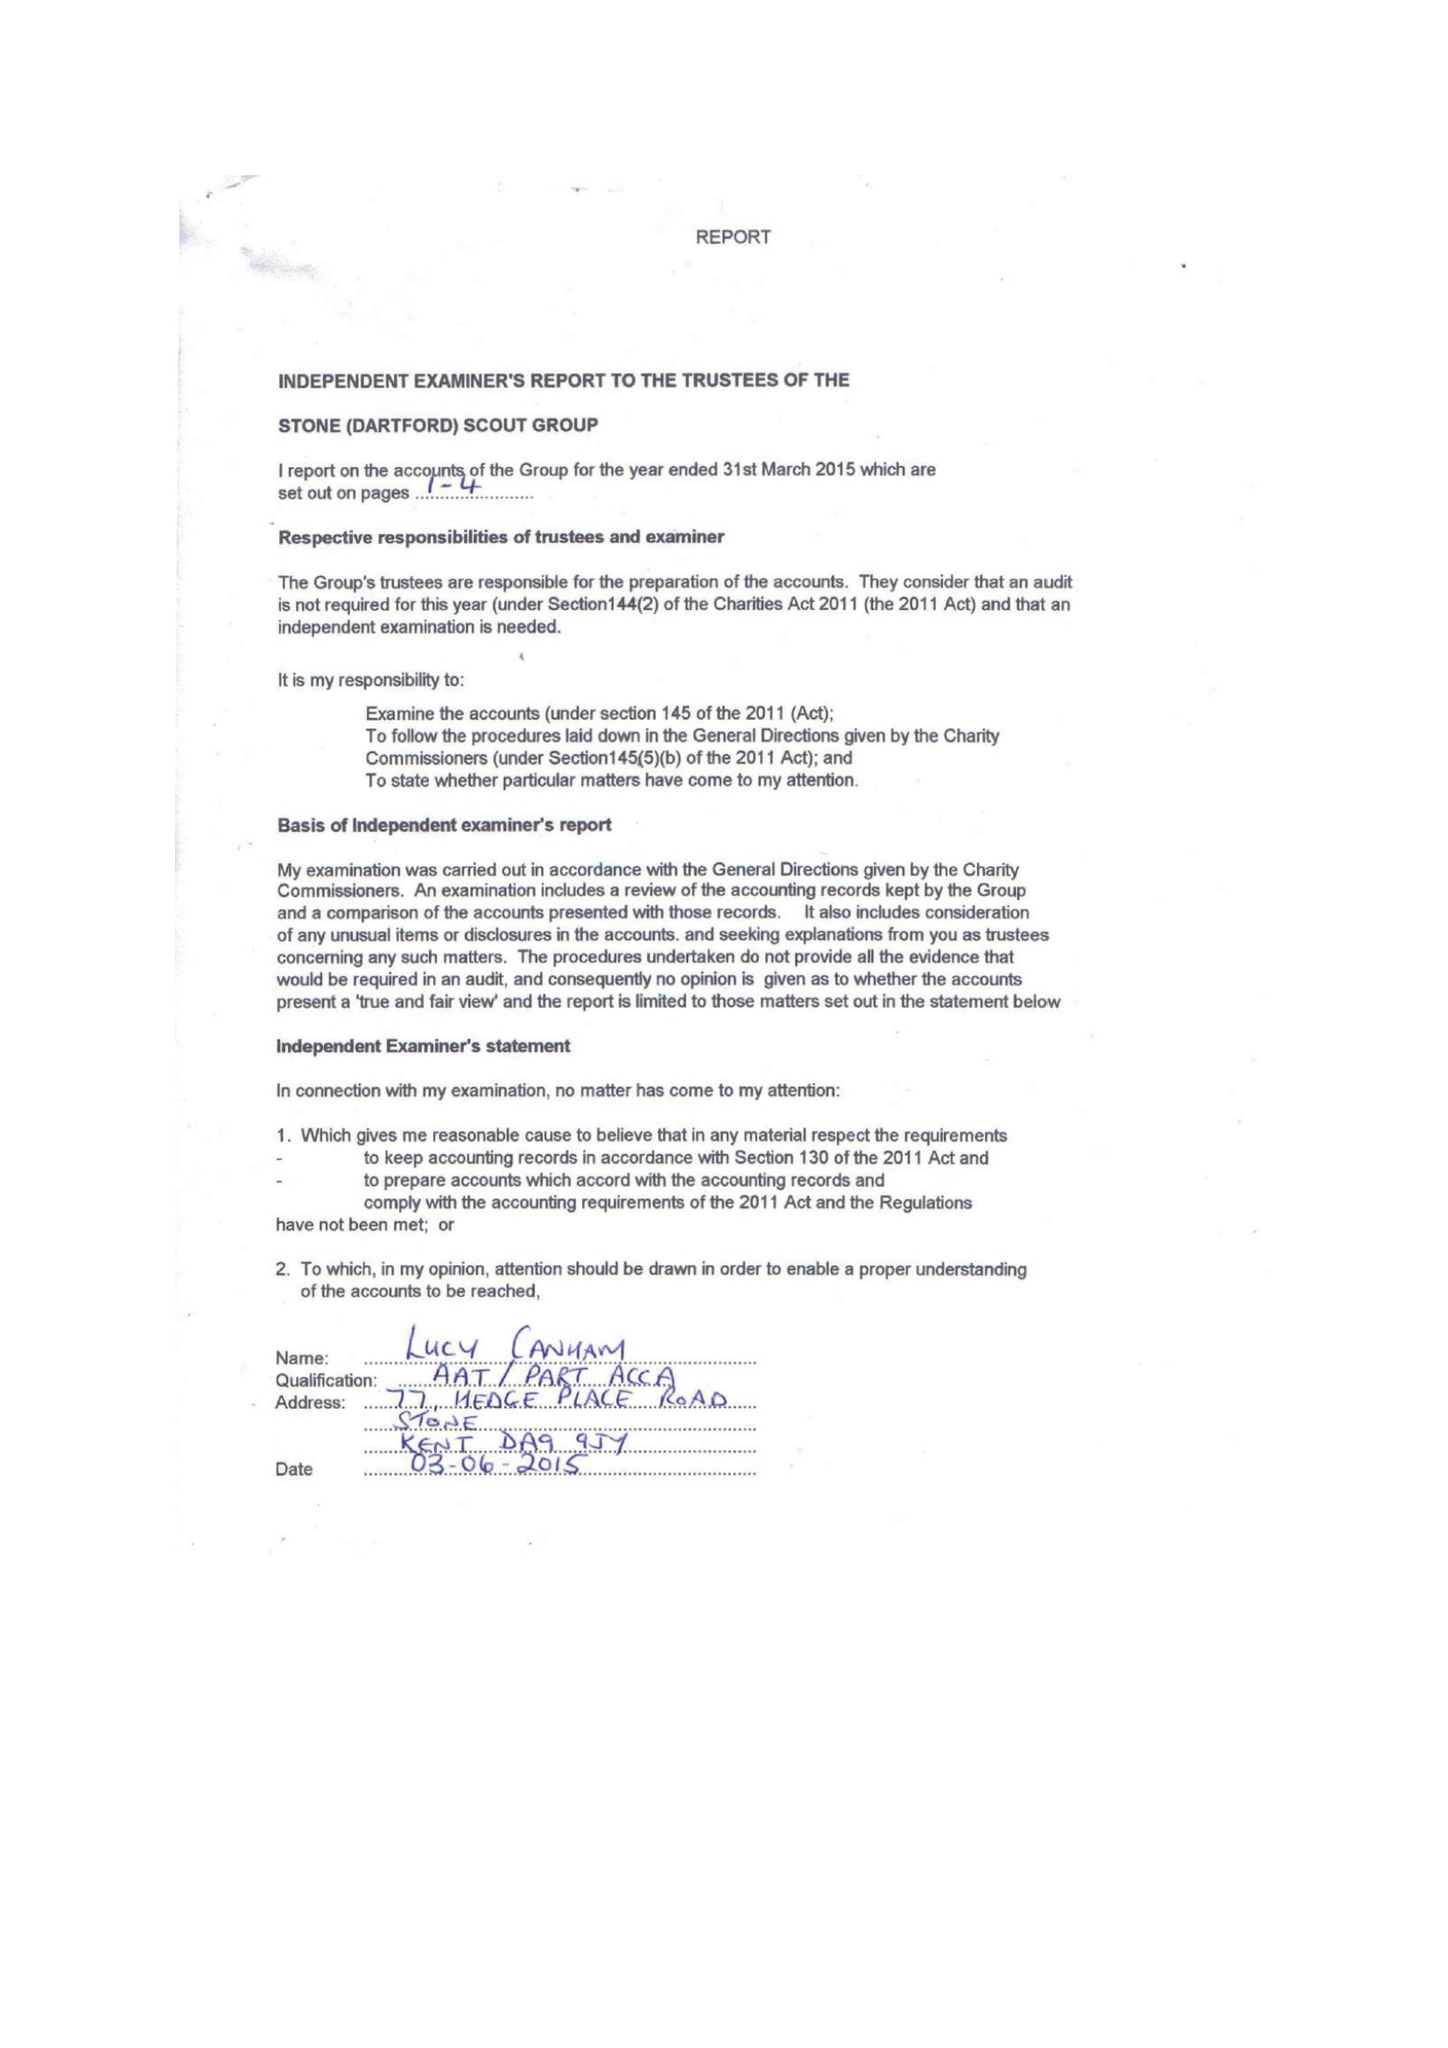What is the value for the address__street_line?
Answer the question using a single word or phrase. 1 EAGLES ROAD 